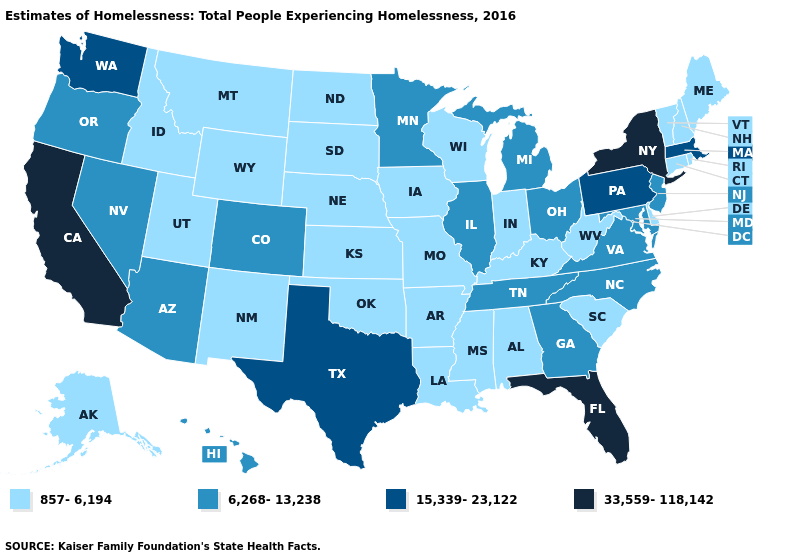Which states hav the highest value in the MidWest?
Concise answer only. Illinois, Michigan, Minnesota, Ohio. Among the states that border Maryland , which have the highest value?
Quick response, please. Pennsylvania. Does New York have the same value as Arizona?
Answer briefly. No. Name the states that have a value in the range 33,559-118,142?
Answer briefly. California, Florida, New York. What is the value of Nevada?
Short answer required. 6,268-13,238. Name the states that have a value in the range 15,339-23,122?
Write a very short answer. Massachusetts, Pennsylvania, Texas, Washington. Which states have the lowest value in the South?
Quick response, please. Alabama, Arkansas, Delaware, Kentucky, Louisiana, Mississippi, Oklahoma, South Carolina, West Virginia. Does the map have missing data?
Answer briefly. No. What is the value of Nevada?
Be succinct. 6,268-13,238. Does Minnesota have the lowest value in the MidWest?
Quick response, please. No. Does Mississippi have the same value as Delaware?
Answer briefly. Yes. Does West Virginia have the same value as Virginia?
Be succinct. No. What is the lowest value in the Northeast?
Be succinct. 857-6,194. What is the lowest value in the USA?
Answer briefly. 857-6,194. Does South Dakota have the same value as Louisiana?
Quick response, please. Yes. 